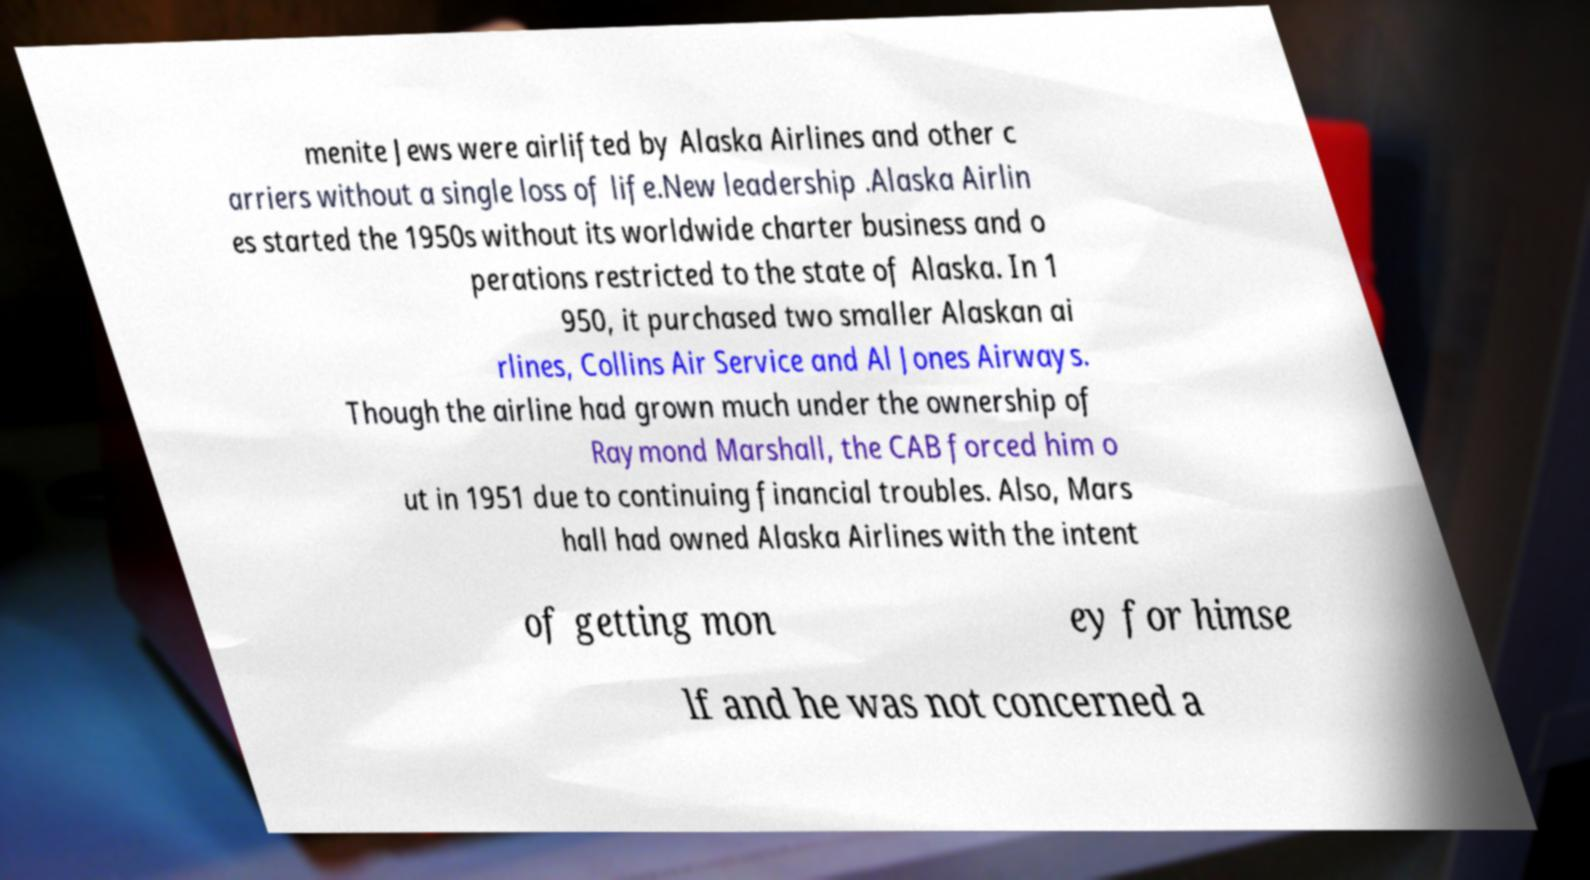Can you read and provide the text displayed in the image?This photo seems to have some interesting text. Can you extract and type it out for me? menite Jews were airlifted by Alaska Airlines and other c arriers without a single loss of life.New leadership .Alaska Airlin es started the 1950s without its worldwide charter business and o perations restricted to the state of Alaska. In 1 950, it purchased two smaller Alaskan ai rlines, Collins Air Service and Al Jones Airways. Though the airline had grown much under the ownership of Raymond Marshall, the CAB forced him o ut in 1951 due to continuing financial troubles. Also, Mars hall had owned Alaska Airlines with the intent of getting mon ey for himse lf and he was not concerned a 